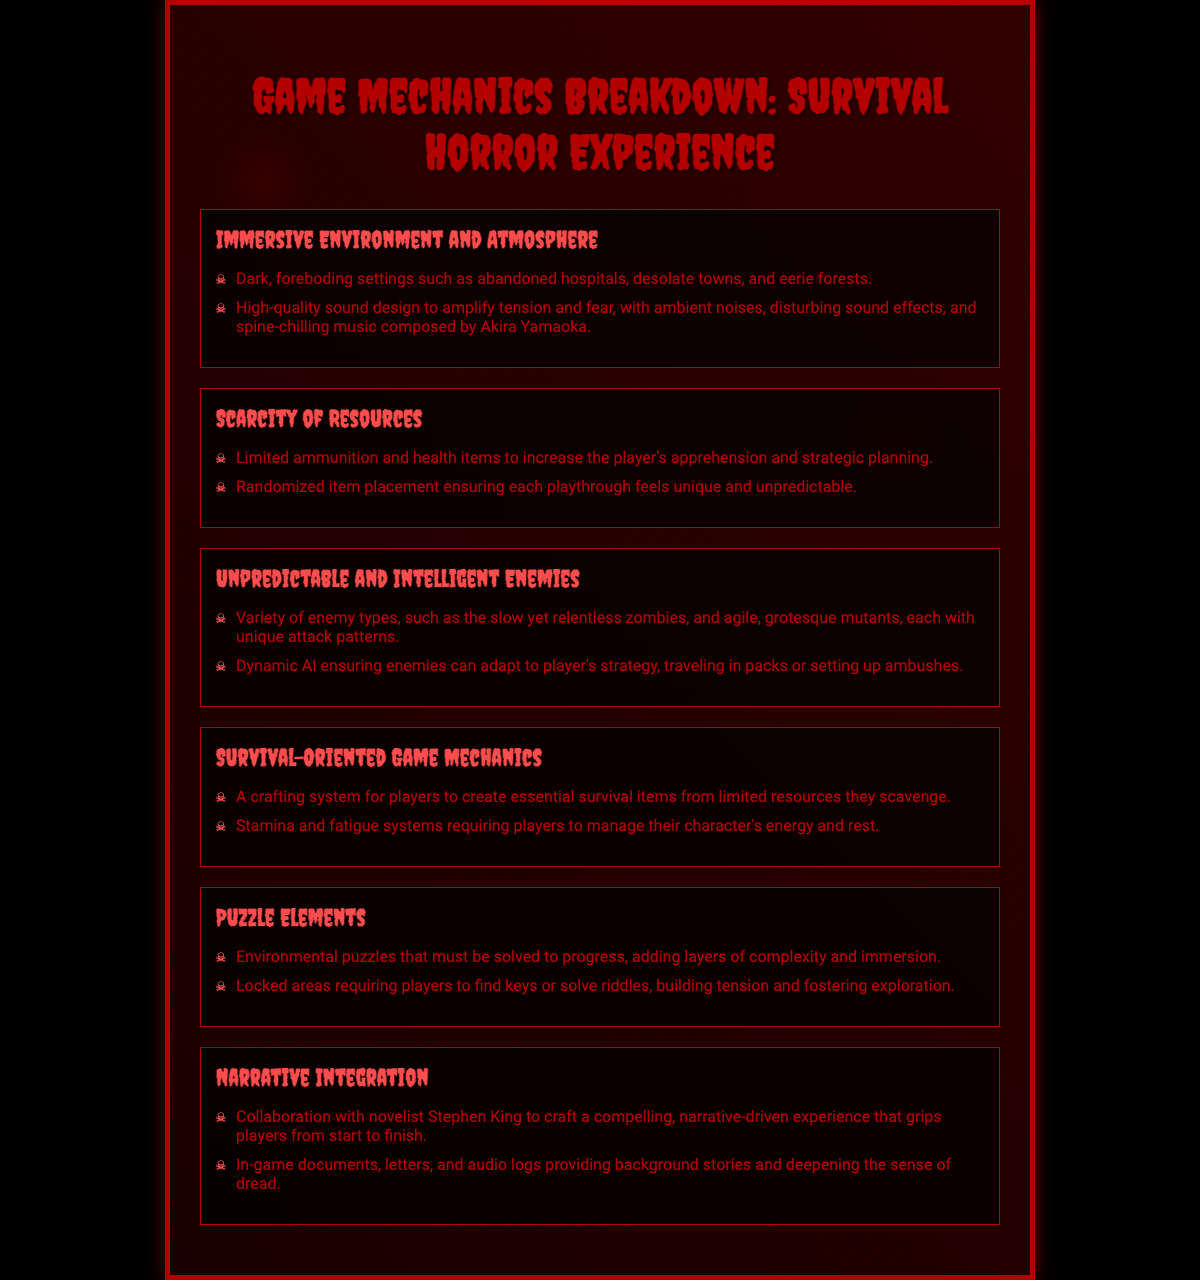What is the main theme of the poster? The main theme of the poster is the breakdown of game mechanics that reflect a survival horror experience.
Answer: Survival Horror Experience Who is the composer mentioned for the sound design? The poster mentions Akira Yamaoka as the composer for the sound design.
Answer: Akira Yamaoka What type of game mechanics are emphasized in the document? The mechanics emphasized include survival-oriented game mechanics, scarcity of resources, and enemy AI dynamics.
Answer: Survival-oriented, Scarcity of resources, Enemy AI How does the environment contribute to gameplay? The environment contributes by being dark and foreboding, enhancing tension and immersion.
Answer: Dark, foreboding settings What aspect of gameplay varies in each playthrough? Randomized item placement ensures that gameplay feels unique and unpredictable each time.
Answer: Randomized item placement What narrative element is integrated into the game? The game features collaboration with a novelist, specifically Stephen King, for narrative depth.
Answer: Collaboration with Stephen King How many sections are there in the poster? The poster contains six distinct sections covering different game mechanics and themes.
Answer: Six What type of challenges will players face regarding items? Players will face a scarcity of resources, leading to increased strategy and planning.
Answer: Scarcity of resources What type of puzzles are included in the game? The game includes environmental puzzles that must be solved for progression.
Answer: Environmental puzzles 